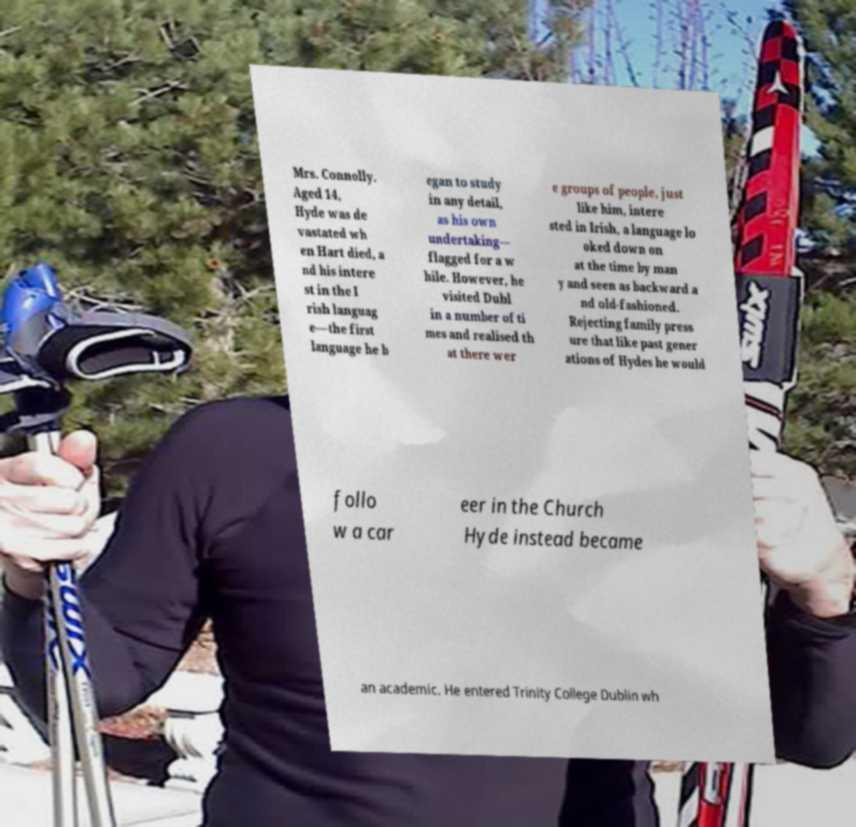I need the written content from this picture converted into text. Can you do that? Mrs. Connolly. Aged 14, Hyde was de vastated wh en Hart died, a nd his intere st in the I rish languag e—the first language he b egan to study in any detail, as his own undertaking— flagged for a w hile. However, he visited Dubl in a number of ti mes and realised th at there wer e groups of people, just like him, intere sted in Irish, a language lo oked down on at the time by man y and seen as backward a nd old-fashioned. Rejecting family press ure that like past gener ations of Hydes he would follo w a car eer in the Church Hyde instead became an academic. He entered Trinity College Dublin wh 